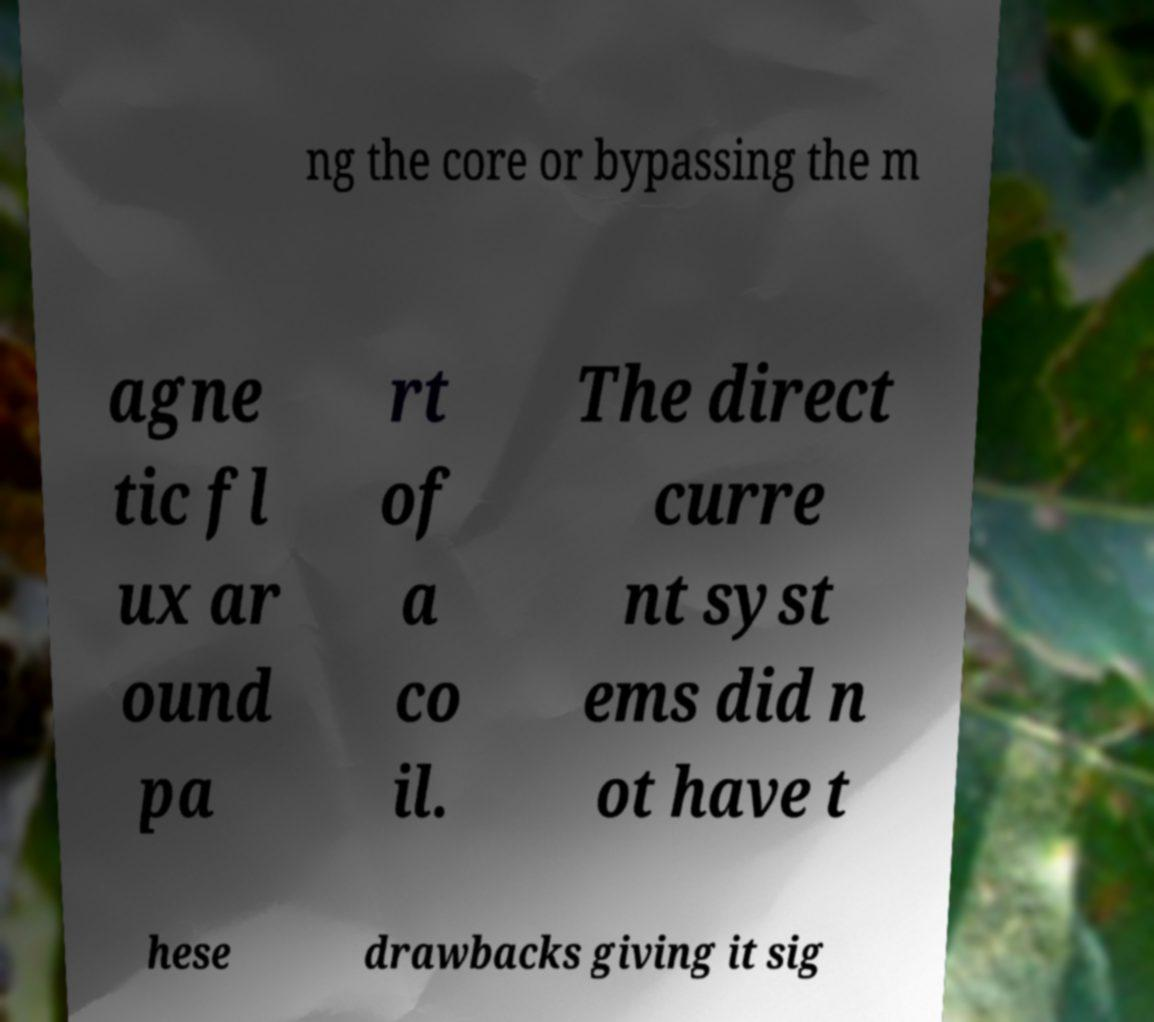I need the written content from this picture converted into text. Can you do that? ng the core or bypassing the m agne tic fl ux ar ound pa rt of a co il. The direct curre nt syst ems did n ot have t hese drawbacks giving it sig 